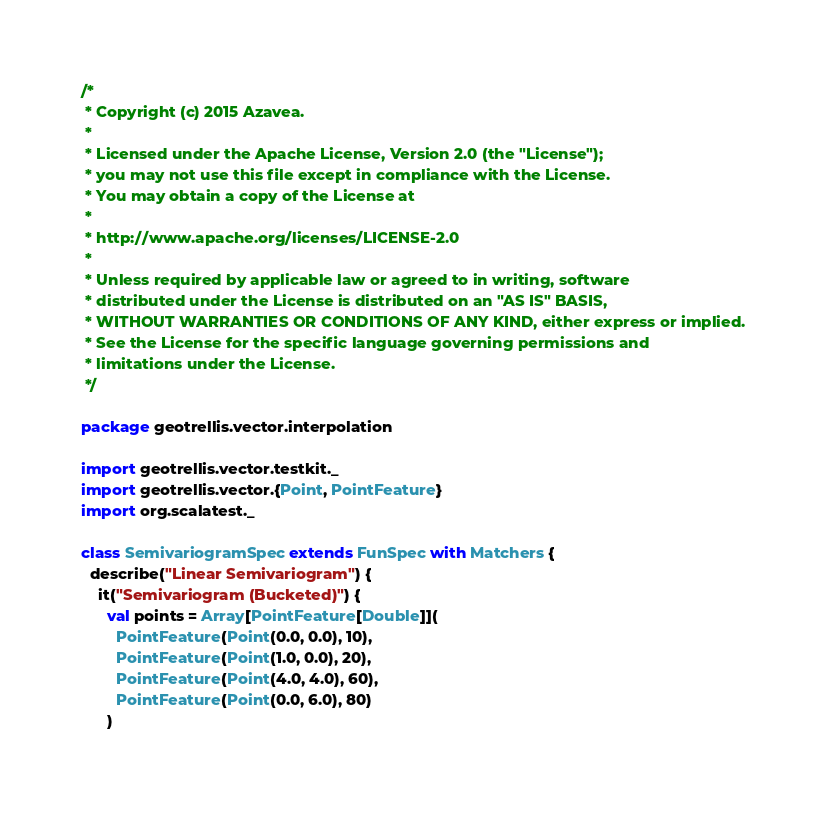Convert code to text. <code><loc_0><loc_0><loc_500><loc_500><_Scala_>/*
 * Copyright (c) 2015 Azavea.
 *
 * Licensed under the Apache License, Version 2.0 (the "License");
 * you may not use this file except in compliance with the License.
 * You may obtain a copy of the License at
 *
 * http://www.apache.org/licenses/LICENSE-2.0
 *
 * Unless required by applicable law or agreed to in writing, software
 * distributed under the License is distributed on an "AS IS" BASIS,
 * WITHOUT WARRANTIES OR CONDITIONS OF ANY KIND, either express or implied.
 * See the License for the specific language governing permissions and
 * limitations under the License.
 */

package geotrellis.vector.interpolation

import geotrellis.vector.testkit._
import geotrellis.vector.{Point, PointFeature}
import org.scalatest._

class SemivariogramSpec extends FunSpec with Matchers {
  describe("Linear Semivariogram") {
    it("Semivariogram (Bucketed)") {
      val points = Array[PointFeature[Double]](
        PointFeature(Point(0.0, 0.0), 10),
        PointFeature(Point(1.0, 0.0), 20),
        PointFeature(Point(4.0, 4.0), 60),
        PointFeature(Point(0.0, 6.0), 80)
      )
</code> 